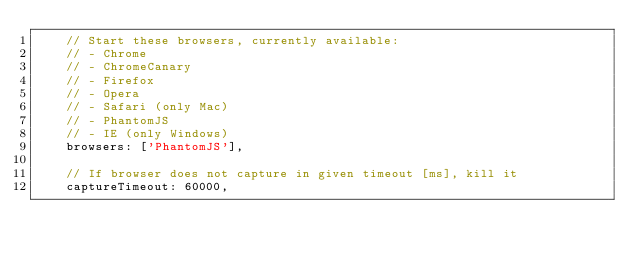<code> <loc_0><loc_0><loc_500><loc_500><_JavaScript_>		// Start these browsers, currently available:
		// - Chrome
		// - ChromeCanary
		// - Firefox
		// - Opera
		// - Safari (only Mac)
		// - PhantomJS
		// - IE (only Windows)
		browsers: ['PhantomJS'],

		// If browser does not capture in given timeout [ms], kill it
		captureTimeout: 60000,
</code> 